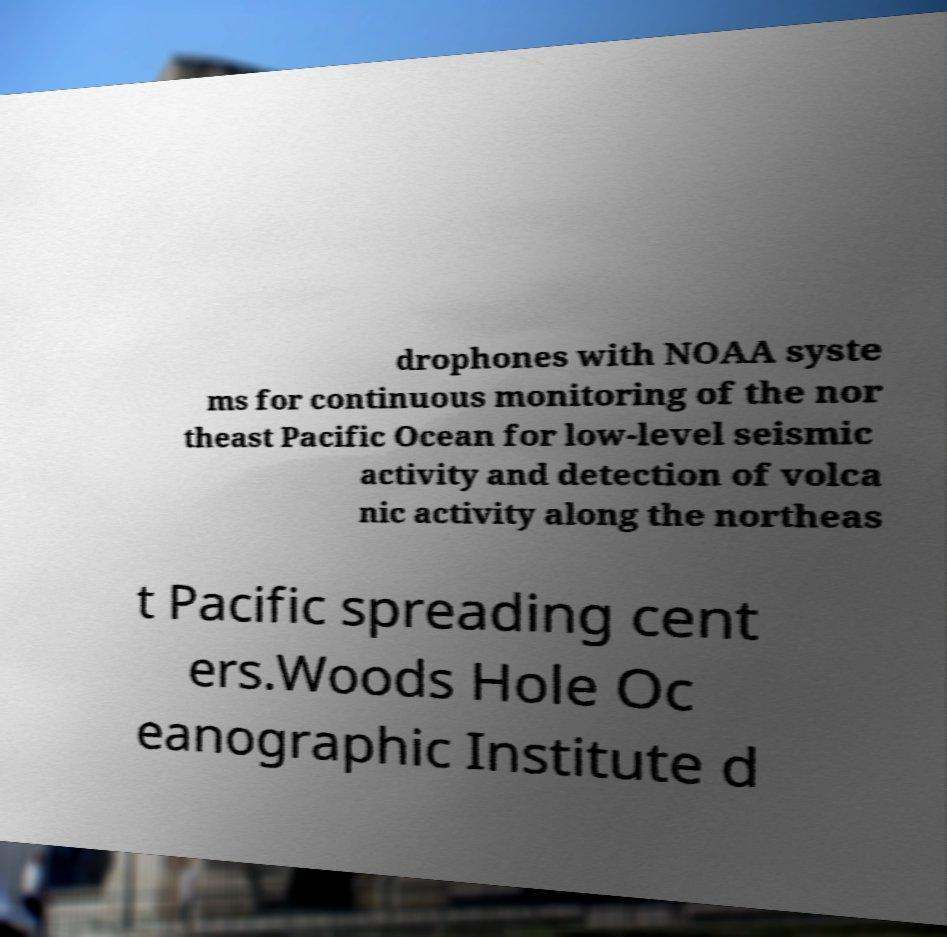Could you extract and type out the text from this image? drophones with NOAA syste ms for continuous monitoring of the nor theast Pacific Ocean for low-level seismic activity and detection of volca nic activity along the northeas t Pacific spreading cent ers.Woods Hole Oc eanographic Institute d 